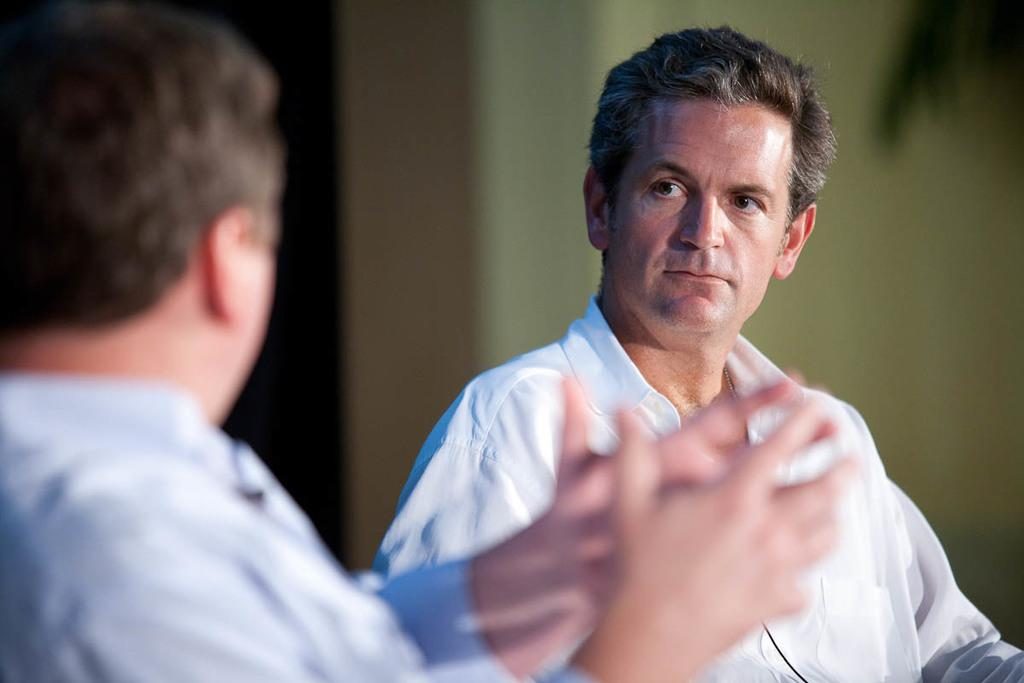How many people are in the image? There are two persons in the image. Can you describe the background of the image? The background of the image is blurry. What type of animal can be seen in the zoo in the image? There is no zoo or animal present in the image; it features two persons with a blurry background. 